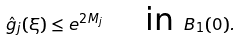Convert formula to latex. <formula><loc_0><loc_0><loc_500><loc_500>\hat { g } _ { j } ( \xi ) \leq e ^ { 2 M _ { j } } \quad \text { in } B _ { 1 } ( 0 ) .</formula> 